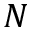<formula> <loc_0><loc_0><loc_500><loc_500>N</formula> 